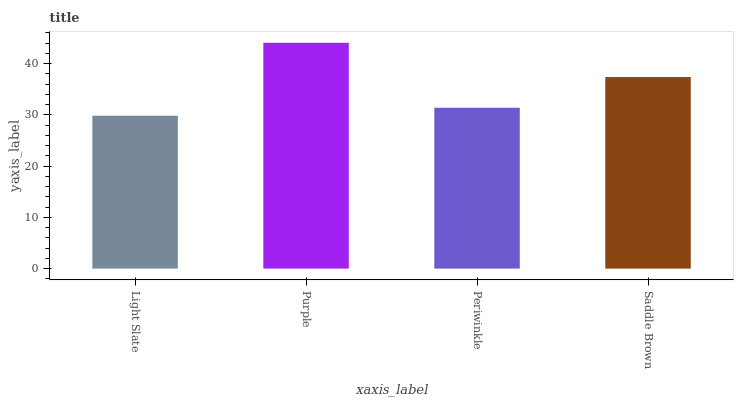Is Light Slate the minimum?
Answer yes or no. Yes. Is Purple the maximum?
Answer yes or no. Yes. Is Periwinkle the minimum?
Answer yes or no. No. Is Periwinkle the maximum?
Answer yes or no. No. Is Purple greater than Periwinkle?
Answer yes or no. Yes. Is Periwinkle less than Purple?
Answer yes or no. Yes. Is Periwinkle greater than Purple?
Answer yes or no. No. Is Purple less than Periwinkle?
Answer yes or no. No. Is Saddle Brown the high median?
Answer yes or no. Yes. Is Periwinkle the low median?
Answer yes or no. Yes. Is Purple the high median?
Answer yes or no. No. Is Light Slate the low median?
Answer yes or no. No. 